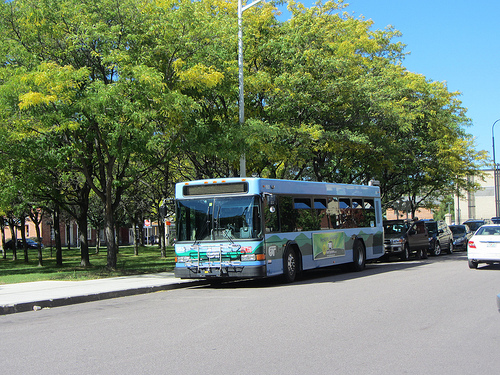What might be the mood and setting if this scene were at night? If this scene were at night, the mood would shift to a more serene and tranquil atmosphere. The street lights would cast a warm, golden glow on the road and the sides of the bus. The sky would be a deep, star-studded expanse, and the leaves on the trees would rustle gently in the cool night air. The bus's headlights would create a soft, illuminating path ahead. The quiet of the night would be punctuated by the distant sounds of the city slowing down, with only the occasional noise from late-night commuters or the rustling of nocturnal creatures. How would a busy weekday morning differ in this sharegpt4v/same setting? On a busy weekday morning, the setting would be quite different. The street would be bustling with activity as people head to work and children to school. The air would be filled with the mixed sounds of bus engines, car horns, and the chatter of people. The sidewalk would be a stream of pedestrians moving briskly, some grabbing a quick coffee from a nearby vendor. The bus would be a vital part of the morning routine, with passengers impatiently waiting at the stop, glancing at their watches. The morning sun would cast long shadows, adding a sense of urgency and the hustle and bustle typically associated with city life on a weekday morning. 